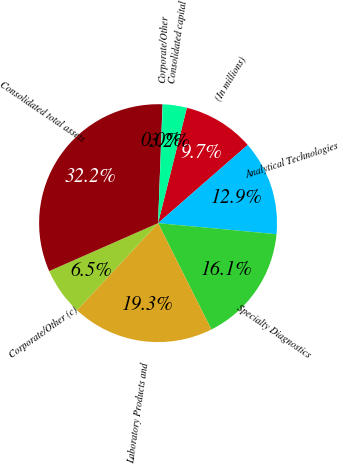<chart> <loc_0><loc_0><loc_500><loc_500><pie_chart><fcel>(In millions)<fcel>Analytical Technologies<fcel>Specialty Diagnostics<fcel>Laboratory Products and<fcel>Corporate/Other (c)<fcel>Consolidated total assets<fcel>Corporate/Other<fcel>Consolidated capital<nl><fcel>9.69%<fcel>12.9%<fcel>16.12%<fcel>19.33%<fcel>6.47%<fcel>32.2%<fcel>0.04%<fcel>3.25%<nl></chart> 